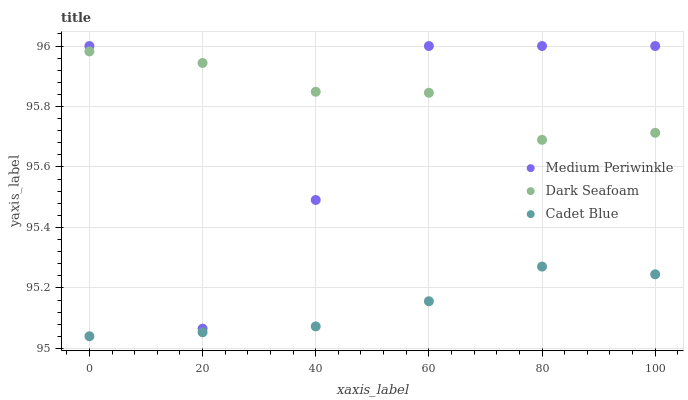Does Cadet Blue have the minimum area under the curve?
Answer yes or no. Yes. Does Dark Seafoam have the maximum area under the curve?
Answer yes or no. Yes. Does Medium Periwinkle have the minimum area under the curve?
Answer yes or no. No. Does Medium Periwinkle have the maximum area under the curve?
Answer yes or no. No. Is Cadet Blue the smoothest?
Answer yes or no. Yes. Is Medium Periwinkle the roughest?
Answer yes or no. Yes. Is Medium Periwinkle the smoothest?
Answer yes or no. No. Is Cadet Blue the roughest?
Answer yes or no. No. Does Cadet Blue have the lowest value?
Answer yes or no. Yes. Does Medium Periwinkle have the lowest value?
Answer yes or no. No. Does Medium Periwinkle have the highest value?
Answer yes or no. Yes. Does Cadet Blue have the highest value?
Answer yes or no. No. Is Cadet Blue less than Dark Seafoam?
Answer yes or no. Yes. Is Medium Periwinkle greater than Cadet Blue?
Answer yes or no. Yes. Does Medium Periwinkle intersect Dark Seafoam?
Answer yes or no. Yes. Is Medium Periwinkle less than Dark Seafoam?
Answer yes or no. No. Is Medium Periwinkle greater than Dark Seafoam?
Answer yes or no. No. Does Cadet Blue intersect Dark Seafoam?
Answer yes or no. No. 